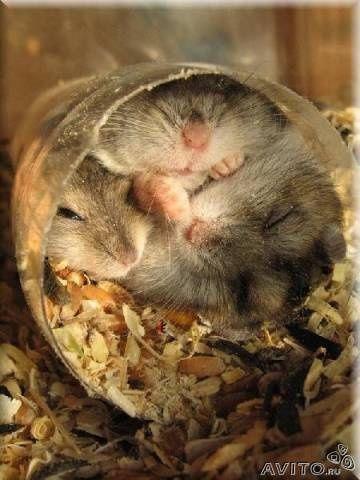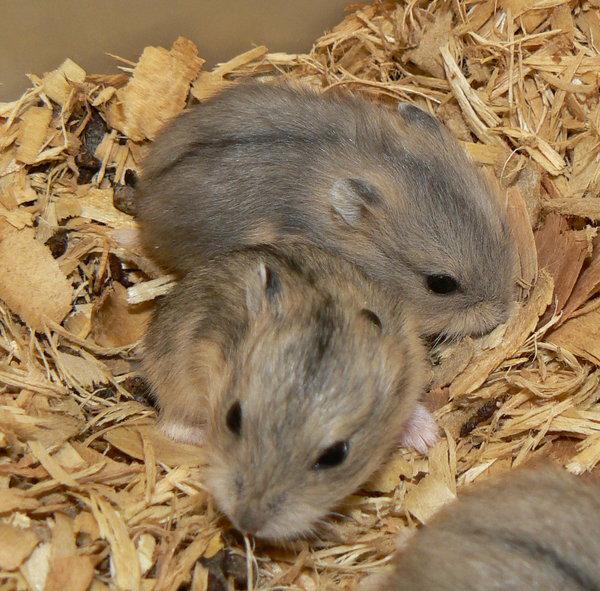The first image is the image on the left, the second image is the image on the right. Analyze the images presented: Is the assertion "More than five rodents are positioned in the woodchips and mulch." valid? Answer yes or no. No. 